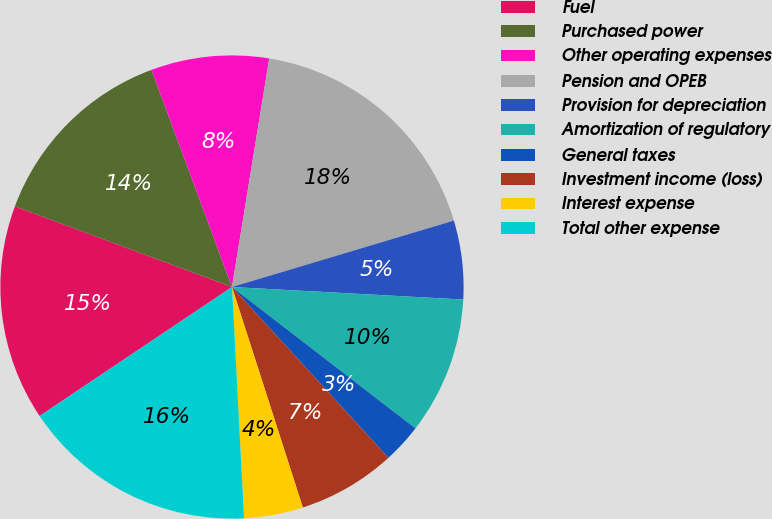Convert chart. <chart><loc_0><loc_0><loc_500><loc_500><pie_chart><fcel>Fuel<fcel>Purchased power<fcel>Other operating expenses<fcel>Pension and OPEB<fcel>Provision for depreciation<fcel>Amortization of regulatory<fcel>General taxes<fcel>Investment income (loss)<fcel>Interest expense<fcel>Total other expense<nl><fcel>15.06%<fcel>13.69%<fcel>8.22%<fcel>17.8%<fcel>5.49%<fcel>9.59%<fcel>2.75%<fcel>6.85%<fcel>4.12%<fcel>16.43%<nl></chart> 